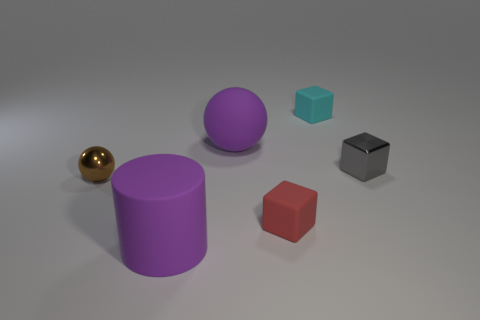There is a small gray shiny cube; how many tiny brown shiny objects are behind it? In the image, there are no tiny brown shiny objects present behind the small gray shiny cube. 